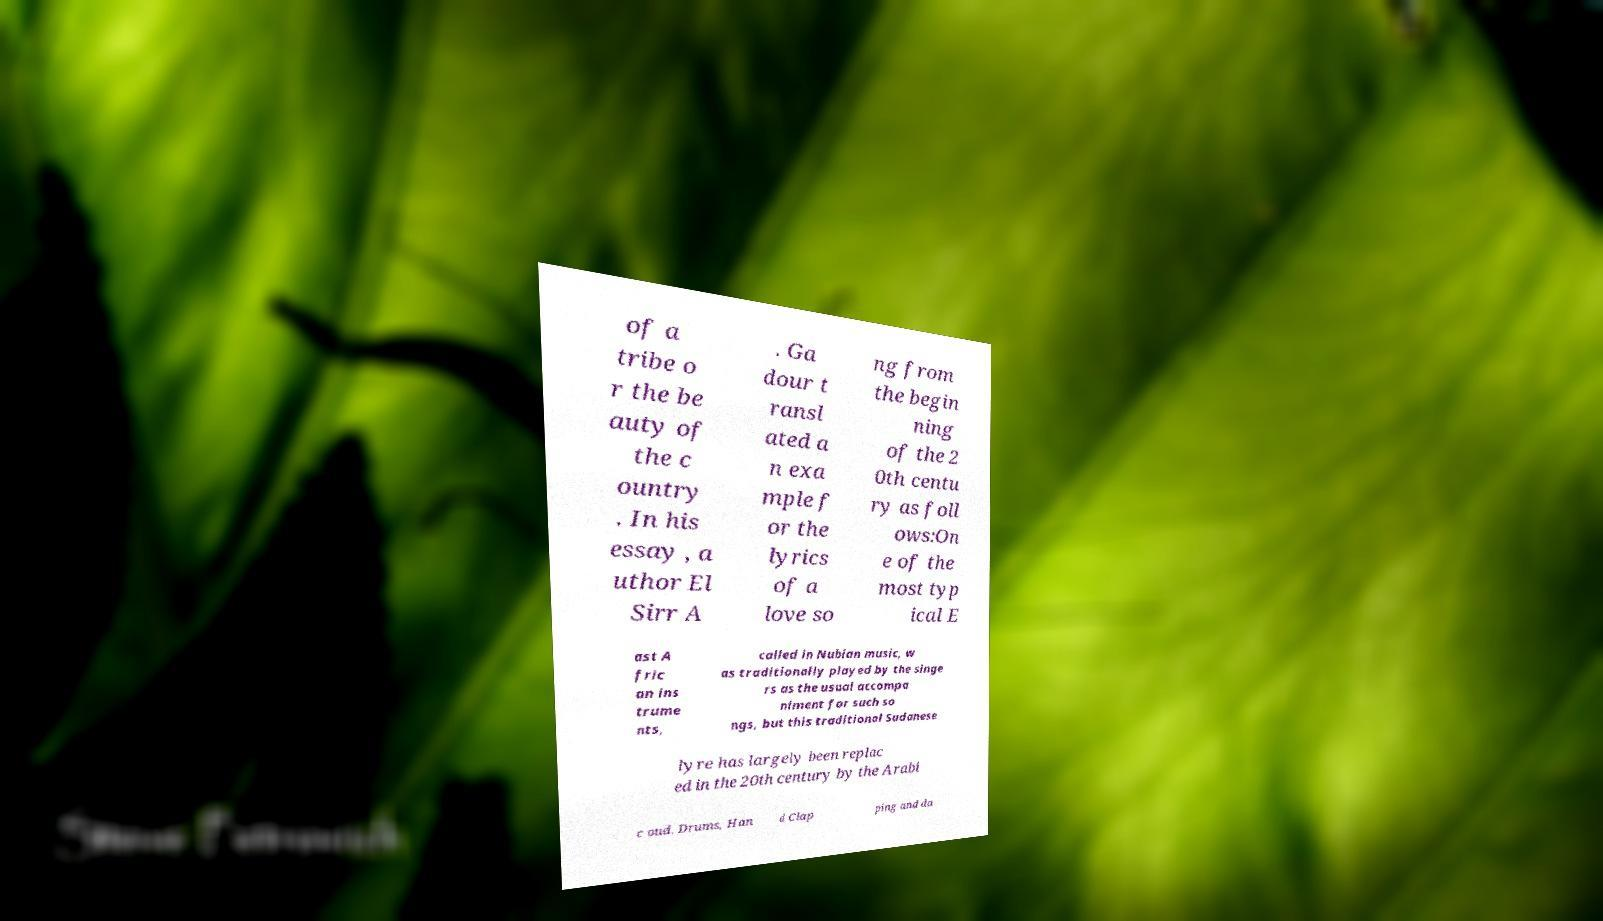Can you accurately transcribe the text from the provided image for me? of a tribe o r the be auty of the c ountry . In his essay , a uthor El Sirr A . Ga dour t ransl ated a n exa mple f or the lyrics of a love so ng from the begin ning of the 2 0th centu ry as foll ows:On e of the most typ ical E ast A fric an ins trume nts, called in Nubian music, w as traditionally played by the singe rs as the usual accompa niment for such so ngs, but this traditional Sudanese lyre has largely been replac ed in the 20th century by the Arabi c oud. Drums, Han d Clap ping and da 